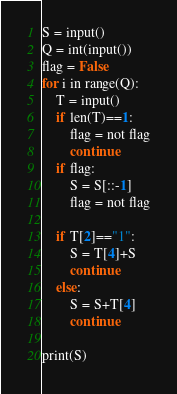Convert code to text. <code><loc_0><loc_0><loc_500><loc_500><_Python_>S = input()
Q = int(input())
flag = False
for i in range(Q):
    T = input()
    if len(T)==1:
        flag = not flag
        continue
    if flag:
        S = S[::-1]
        flag = not flag
        
    if T[2]=="1":
        S = T[4]+S
        continue
    else:
        S = S+T[4]
        continue
    
print(S)</code> 